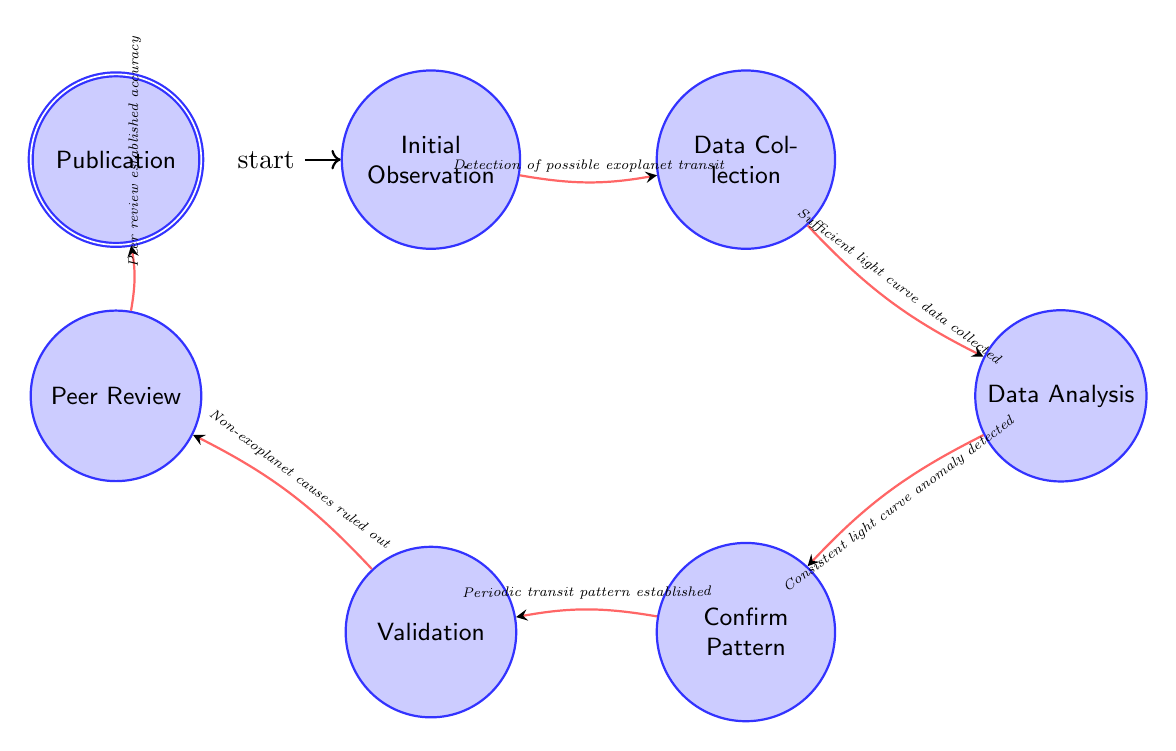What is the initial state of the Finite State Machine? The initial state, indicated in the diagram, is the node labeled "Initial Observation." This is where the sequence begins in confirming an exoplanet using the transit method.
Answer: Initial Observation How many states are present in the diagram? By counting the nodes in the diagram, we find there are seven distinct states, each representing a different stage in the exoplanet confirmation process.
Answer: 7 What action leads from Data Collection to Data Analysis? The transition from the node "Data Collection" to "Data Analysis" is based on the action "Sufficient light curve data collected." This action indicates the necessity of having enough data to proceed with analysis.
Answer: Sufficient light curve data collected Which state immediately follows Validation? In the sequence defined by the transitions in the diagram, the state that follows "Validation" is "Peer Review." This indicates that after validating the transit signal, the findings are submitted for peer verification.
Answer: Peer Review What does the action from Confirm Pattern to Validation confirm? The transition from "Confirm Pattern" to "Validation" is triggered by establishing a "Periodic transit pattern." This confirms that a consistent transit characteristic has been identified.
Answer: Periodic transit pattern established What is the final state of the Finite State Machine? The last state in the sequence is labeled "Publication," which signifies that the confirmed findings about the exoplanet have been published in a scientific journal.
Answer: Publication What must happen right before the findings are published? Prior to publication, the state "Peer Review" must be reached, confirming that the accuracy of the findings has been established through peer verification processes.
Answer: Peer review established accuracy 